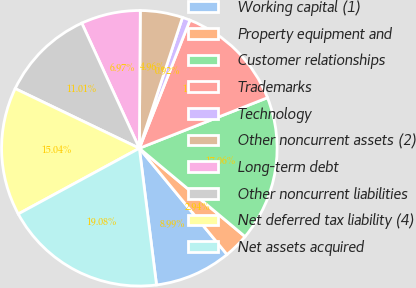Convert chart. <chart><loc_0><loc_0><loc_500><loc_500><pie_chart><fcel>Working capital (1)<fcel>Property equipment and<fcel>Customer relationships<fcel>Trademarks<fcel>Technology<fcel>Other noncurrent assets (2)<fcel>Long-term debt<fcel>Other noncurrent liabilities<fcel>Net deferred tax liability (4)<fcel>Net assets acquired<nl><fcel>8.99%<fcel>2.94%<fcel>17.06%<fcel>13.03%<fcel>0.92%<fcel>4.96%<fcel>6.97%<fcel>11.01%<fcel>15.04%<fcel>19.08%<nl></chart> 